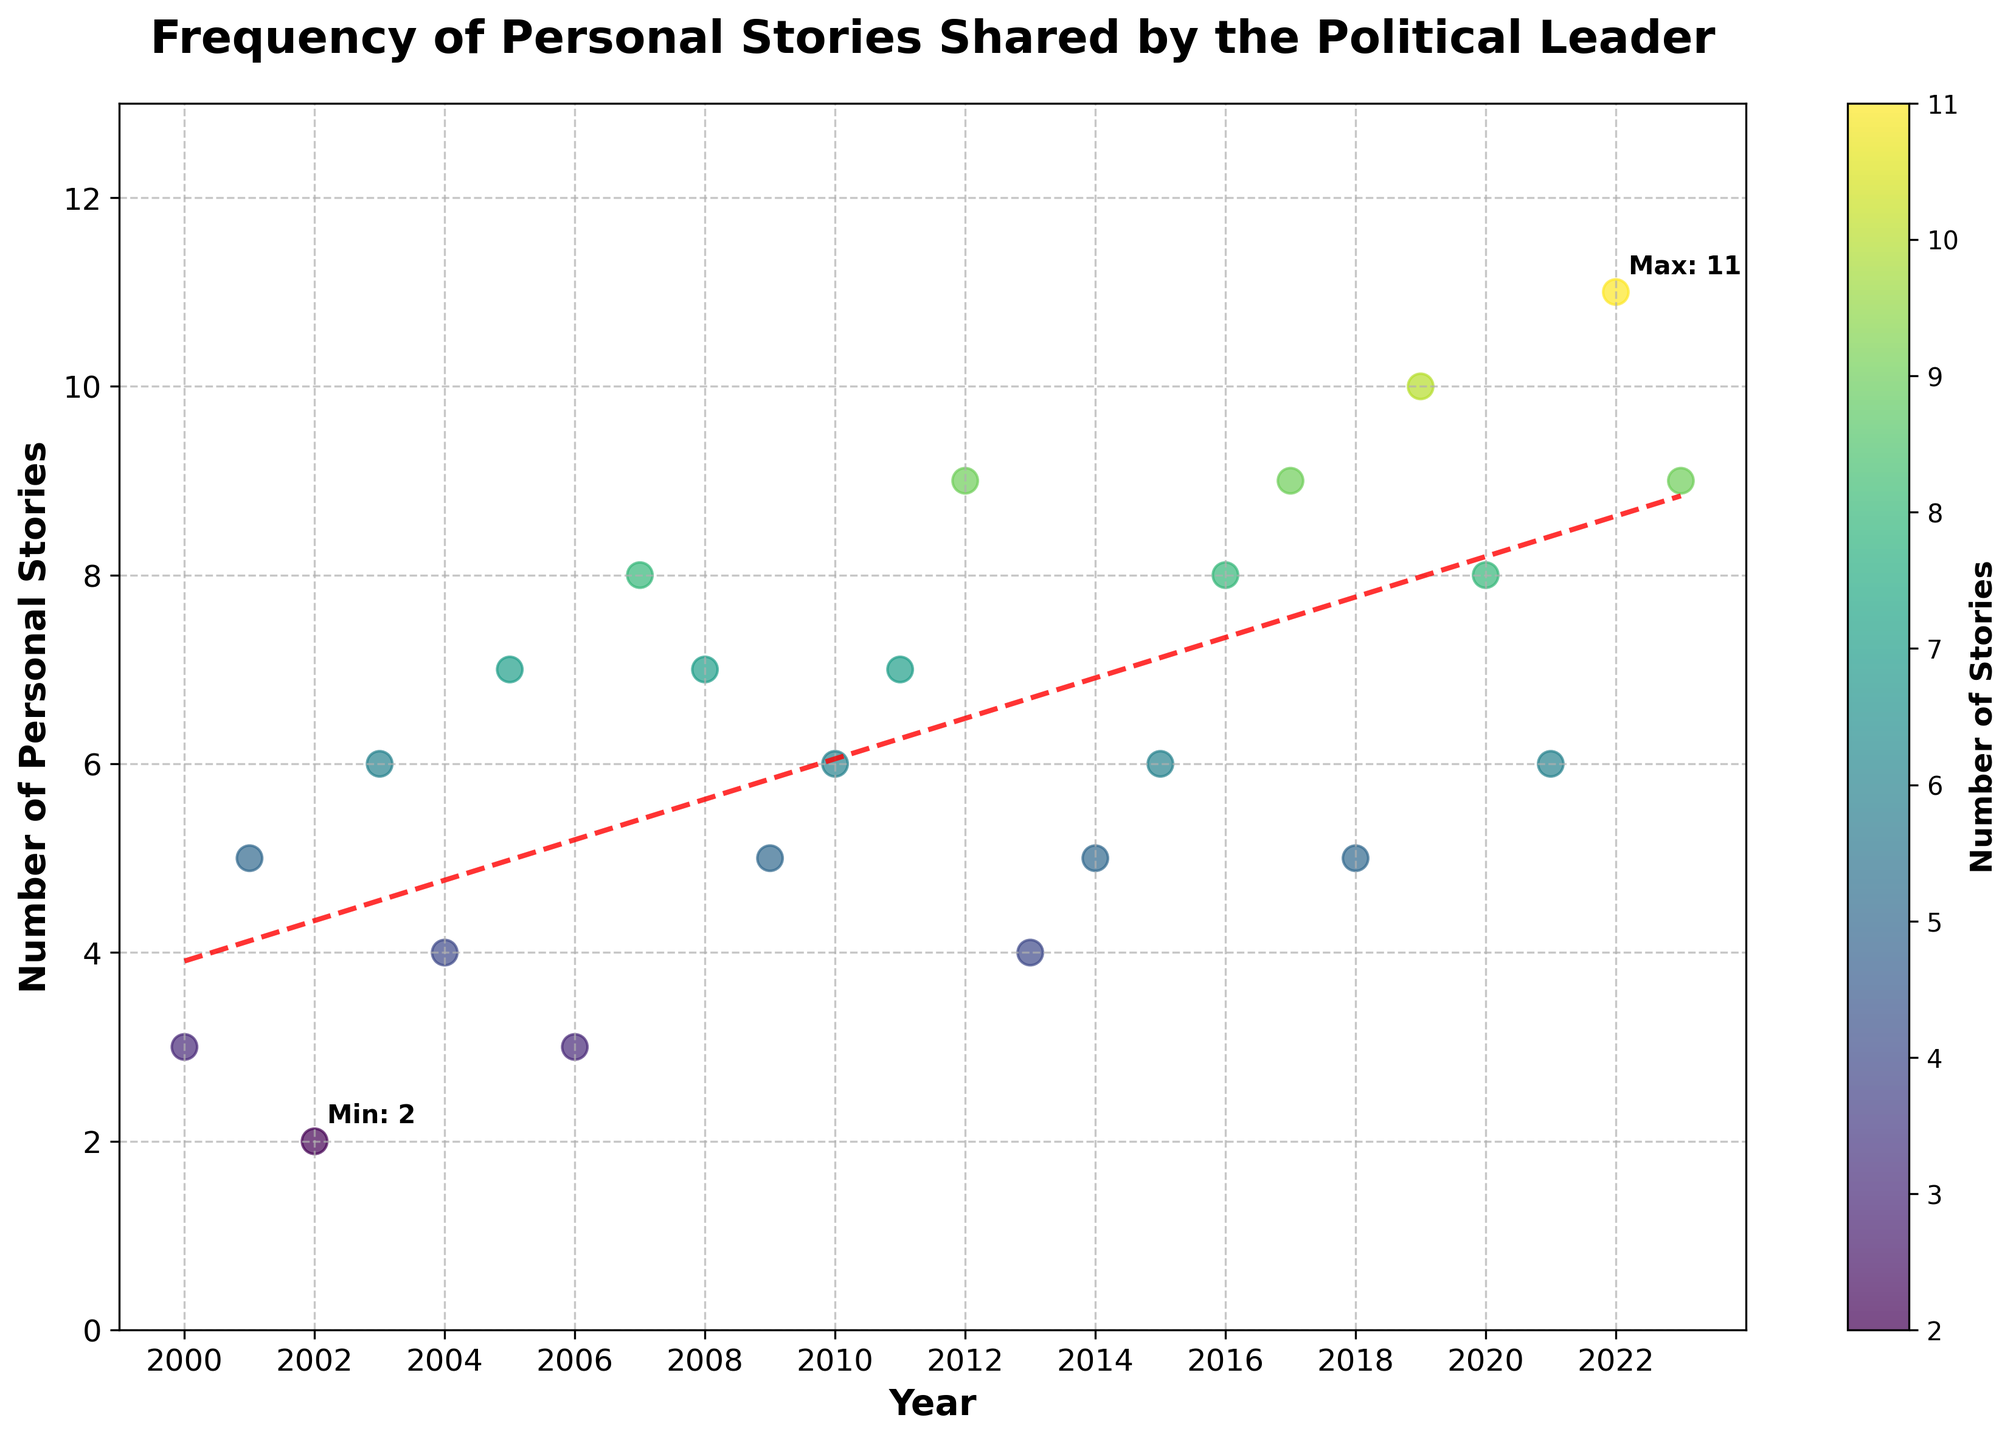What's the title of the scatter plot? The title is usually written at the top of the figure and describes the main topic of the plot. In this case, it describes the frequency of personal stories shared by the political leader.
Answer: Frequency of Personal Stories Shared by the Political Leader What are the x-axis and y-axis labels? The x-axis label is found at the bottom of the scatter plot, and the y-axis label is found on the left side. They describe what each axis represents.
Answer: Year; Number of Personal Stories Which year had the highest number of personal stories shared? By inspecting the plot, you can see which point on the scatter plot is the highest. The year corresponding to that point is the one with the highest number of personal stories shared.
Answer: 2022 During which year did the political leader share the fewest personal stories? To find the lowest number of points on the scatter plot and identify the respective year.
Answer: 2002 How many personal stories did the political leader share in 2005? Locate the year 2005 on the x-axis and trace it to the corresponding point on the scatter plot. The y-value of this point gives the number of personal stories.
Answer: 7 What is the general trend of the number of personal stories shared over the years? Look at the trend line added to the scatter plot. The slope of the trend line indicates whether the number of personal stories has generally increased, decreased, or remained stable over time.
Answer: Increased Between which years did the number of personal stories shared decrease the most significantly? Compare the heights of the points on the scatter plot to identify the largest drop between two years.
Answer: 2003 to 2004 What is the average number of personal stories shared per year from 2015 to 2020? Identify the points corresponding to the years 2015 to 2020, add the number of personal stories shared, and divide by the number of years (6).
Answer: (6+8+9+5+10+8)/6 = 7.67 Does the political leader share more personal stories in the earlier or later years of the timeline? Compare the density of points and their heights in the earlier years (2000-2010) vs. the later years (2011-2023) on the scatter plot.
Answer: Later years What is the difference in the number of personal stories shared between 2008 and 2018? Locate the points for the years 2008 and 2018 on the scatter plot. Subtract the number of stories in 2008 from the number in 2018.
Answer: 5 - 7 = 2 